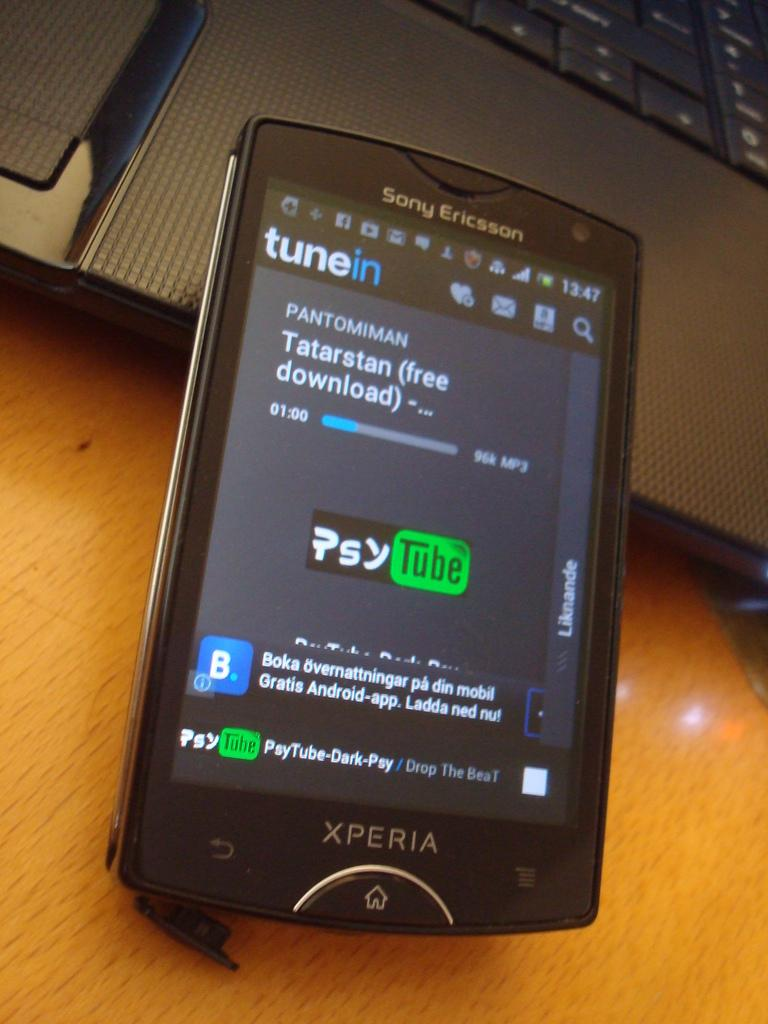Provide a one-sentence caption for the provided image. a Sony Ericsson cell phone is powered on. 